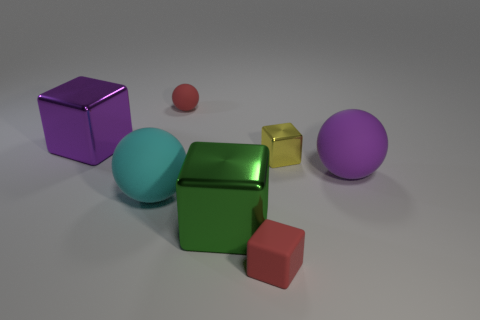Are there fewer tiny cubes right of the big purple block than blocks that are on the left side of the small yellow shiny object?
Your answer should be very brief. Yes. What shape is the matte thing that is the same color as the tiny sphere?
Offer a terse response. Cube. How many other purple shiny blocks are the same size as the purple metal block?
Give a very brief answer. 0. Does the sphere to the right of the big green thing have the same material as the green object?
Make the answer very short. No. Are there any green metal spheres?
Provide a succinct answer. No. What size is the purple sphere that is the same material as the red ball?
Provide a short and direct response. Large. Are there any tiny things that have the same color as the small matte cube?
Offer a very short reply. Yes. Do the big metal cube behind the large cyan object and the big object on the right side of the big green cube have the same color?
Provide a short and direct response. Yes. There is a thing that is the same color as the tiny rubber block; what size is it?
Provide a short and direct response. Small. Are there any cubes that have the same material as the yellow thing?
Give a very brief answer. Yes. 